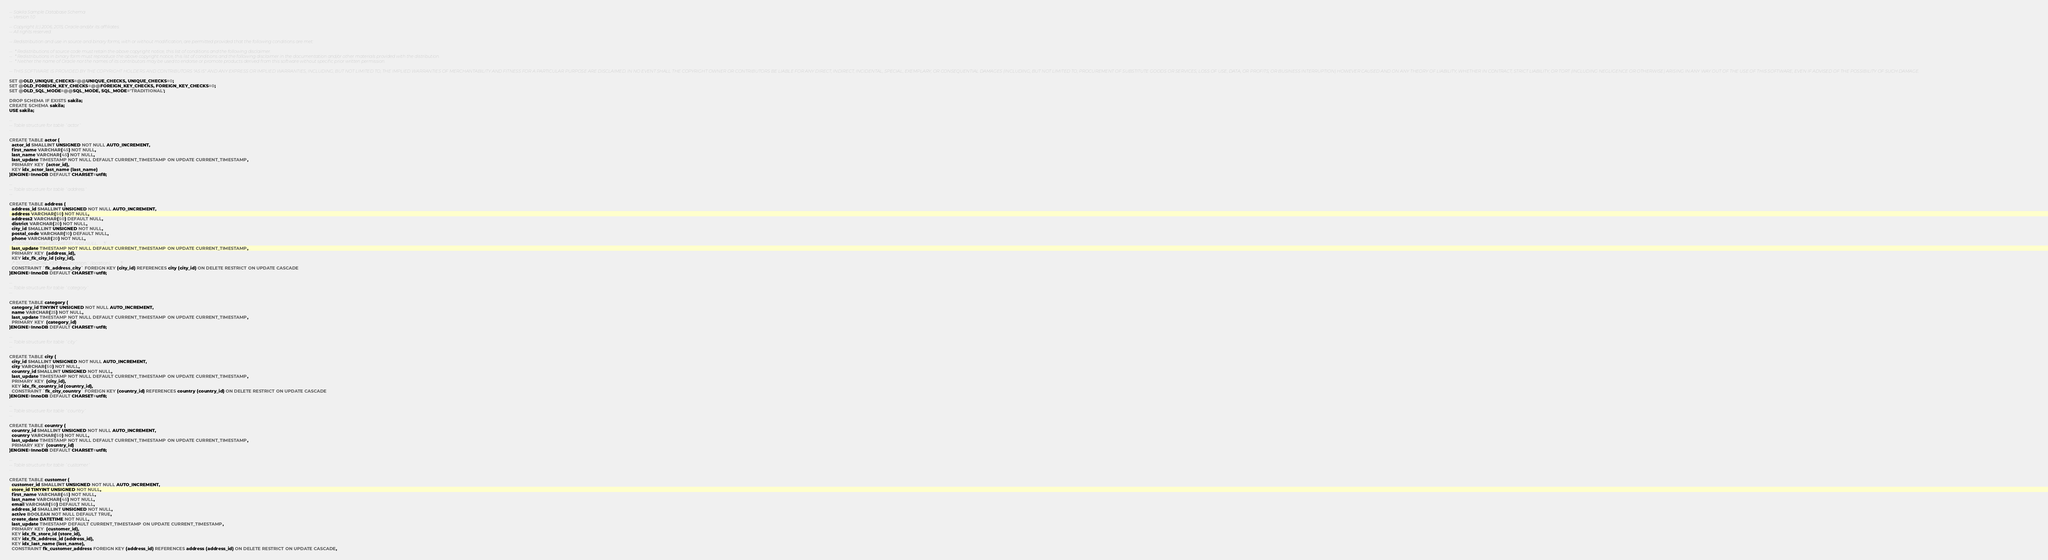<code> <loc_0><loc_0><loc_500><loc_500><_SQL_>-- Sakila Sample Database Schema
-- Version 1.0

-- Copyright (c) 2006, 2015, Oracle and/or its affiliates. 
-- All rights reserved.

-- Redistribution and use in source and binary forms, with or without modification, are permitted provided that the following conditions are met:

--  * Redistributions of source code must retain the above copyright notice, this list of conditions and the following disclaimer.
--  * Redistributions in binary form must reproduce the above copyright notice, this list of conditions and the following disclaimer in the documentation and/or other materials provided with the distribution.
--  * Neither the name of Oracle nor the names of its contributors may be used to endorse or promote products derived from this software without specific prior written permission.

-- THIS SOFTWARE IS PROVIDED BY THE COPYRIGHT HOLDERS AND CONTRIBUTORS "AS IS" AND ANY EXPRESS OR IMPLIED WARRANTIES, INCLUDING, BUT NOT LIMITED TO, THE IMPLIED WARRANTIES OF MERCHANTABILITY AND FITNESS FOR A PARTICULAR PURPOSE ARE DISCLAIMED. IN NO EVENT SHALL THE COPYRIGHT OWNER OR CONTRIBUTORS BE LIABLE FOR ANY DIRECT, INDIRECT, INCIDENTAL, SPECIAL, EXEMPLARY, OR CONSEQUENTIAL DAMAGES (INCLUDING, BUT NOT LIMITED TO, PROCUREMENT OF SUBSTITUTE GOODS OR SERVICES; LOSS OF USE, DATA, OR PROFITS; OR BUSINESS INTERRUPTION) HOWEVER CAUSED AND ON ANY THEORY OF LIABILITY, WHETHER IN CONTRACT, STRICT LIABILITY, OR TORT (INCLUDING NEGLIGENCE OR OTHERWISE) ARISING IN ANY WAY OUT OF THE USE OF THIS SOFTWARE, EVEN IF ADVISED OF THE POSSIBILITY OF SUCH DAMAGE.

SET @OLD_UNIQUE_CHECKS=@@UNIQUE_CHECKS, UNIQUE_CHECKS=0;
SET @OLD_FOREIGN_KEY_CHECKS=@@FOREIGN_KEY_CHECKS, FOREIGN_KEY_CHECKS=0;
SET @OLD_SQL_MODE=@@SQL_MODE, SQL_MODE='TRADITIONAL';

DROP SCHEMA IF EXISTS sakila;
CREATE SCHEMA sakila;
USE sakila;

--
-- Table structure for table `actor`
--

CREATE TABLE actor (
  actor_id SMALLINT UNSIGNED NOT NULL AUTO_INCREMENT,
  first_name VARCHAR(45) NOT NULL,
  last_name VARCHAR(45) NOT NULL,
  last_update TIMESTAMP NOT NULL DEFAULT CURRENT_TIMESTAMP ON UPDATE CURRENT_TIMESTAMP,
  PRIMARY KEY  (actor_id),
  KEY idx_actor_last_name (last_name)
)ENGINE=InnoDB DEFAULT CHARSET=utf8;

--
-- Table structure for table `address`
--

CREATE TABLE address (
  address_id SMALLINT UNSIGNED NOT NULL AUTO_INCREMENT,
  address VARCHAR(50) NOT NULL,
  address2 VARCHAR(50) DEFAULT NULL,
  district VARCHAR(20) NOT NULL,
  city_id SMALLINT UNSIGNED NOT NULL,
  postal_code VARCHAR(10) DEFAULT NULL,
  phone VARCHAR(20) NOT NULL,
  /*!50705 location GEOMETRY NOT NULL,*/
  last_update TIMESTAMP NOT NULL DEFAULT CURRENT_TIMESTAMP ON UPDATE CURRENT_TIMESTAMP,
  PRIMARY KEY  (address_id),
  KEY idx_fk_city_id (city_id),
  /*!50705 SPATIAL KEY `idx_location` (location),*/
  CONSTRAINT `fk_address_city` FOREIGN KEY (city_id) REFERENCES city (city_id) ON DELETE RESTRICT ON UPDATE CASCADE
)ENGINE=InnoDB DEFAULT CHARSET=utf8;

--
-- Table structure for table `category`
--

CREATE TABLE category (
  category_id TINYINT UNSIGNED NOT NULL AUTO_INCREMENT,
  name VARCHAR(25) NOT NULL,
  last_update TIMESTAMP NOT NULL DEFAULT CURRENT_TIMESTAMP ON UPDATE CURRENT_TIMESTAMP,
  PRIMARY KEY  (category_id)
)ENGINE=InnoDB DEFAULT CHARSET=utf8;

--
-- Table structure for table `city`
--

CREATE TABLE city (
  city_id SMALLINT UNSIGNED NOT NULL AUTO_INCREMENT,
  city VARCHAR(50) NOT NULL,
  country_id SMALLINT UNSIGNED NOT NULL,
  last_update TIMESTAMP NOT NULL DEFAULT CURRENT_TIMESTAMP ON UPDATE CURRENT_TIMESTAMP,
  PRIMARY KEY  (city_id),
  KEY idx_fk_country_id (country_id),
  CONSTRAINT `fk_city_country` FOREIGN KEY (country_id) REFERENCES country (country_id) ON DELETE RESTRICT ON UPDATE CASCADE
)ENGINE=InnoDB DEFAULT CHARSET=utf8;

--
-- Table structure for table `country`
--

CREATE TABLE country (
  country_id SMALLINT UNSIGNED NOT NULL AUTO_INCREMENT,
  country VARCHAR(50) NOT NULL,
  last_update TIMESTAMP NOT NULL DEFAULT CURRENT_TIMESTAMP ON UPDATE CURRENT_TIMESTAMP,
  PRIMARY KEY  (country_id)
)ENGINE=InnoDB DEFAULT CHARSET=utf8;

--
-- Table structure for table `customer`
--

CREATE TABLE customer (
  customer_id SMALLINT UNSIGNED NOT NULL AUTO_INCREMENT,
  store_id TINYINT UNSIGNED NOT NULL,
  first_name VARCHAR(45) NOT NULL,
  last_name VARCHAR(45) NOT NULL,
  email VARCHAR(50) DEFAULT NULL,
  address_id SMALLINT UNSIGNED NOT NULL,
  active BOOLEAN NOT NULL DEFAULT TRUE,
  create_date DATETIME NOT NULL,
  last_update TIMESTAMP DEFAULT CURRENT_TIMESTAMP ON UPDATE CURRENT_TIMESTAMP,
  PRIMARY KEY  (customer_id),
  KEY idx_fk_store_id (store_id),
  KEY idx_fk_address_id (address_id),
  KEY idx_last_name (last_name),
  CONSTRAINT fk_customer_address FOREIGN KEY (address_id) REFERENCES address (address_id) ON DELETE RESTRICT ON UPDATE CASCADE,</code> 